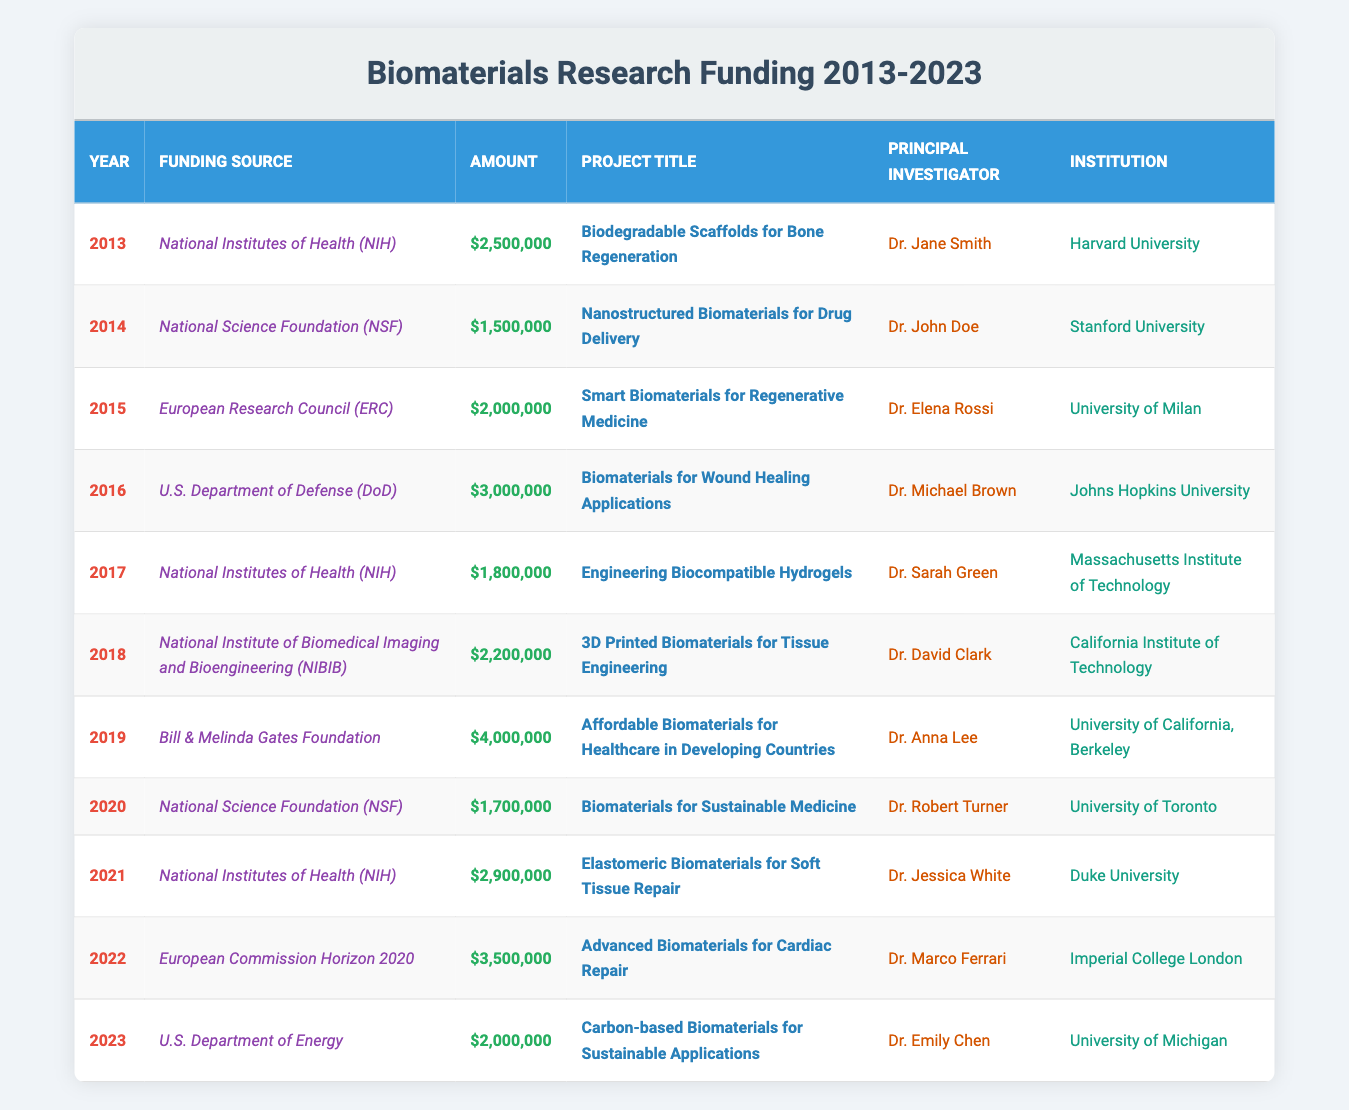What was the largest single funding amount for a biomaterials project during this period? Analyzing the amount column, the largest single funding amount is $4,000,000 which corresponds to the project titled "Affordable Biomaterials for Healthcare in Developing Countries" in 2019.
Answer: $4,000,000 How many projects were funded by the National Institutes of Health (NIH)? Counting the rows where the source is "National Institutes of Health (NIH)", we find 4 projects listed in the table: 2013, 2017, 2021.
Answer: 4 What is the total funding amount received by projects from the National Science Foundation (NSF)? The funding amounts for NSF are $1,500,000 in 2014 and $1,700,000 in 2020. Adding these gives $1,500,000 + $1,700,000 = $3,200,000.
Answer: $3,200,000 Was there a project funded by the Bill & Melinda Gates Foundation? The table shows that there is indeed a project funded by the Bill & Melinda Gates Foundation, specifically in 2019.
Answer: Yes Which project had the highest funding amount from the U.S. Department of Defense (DoD)? Only one project is listed from DoD, which is "Biomaterials for Wound Healing Applications" in 2016 with a funding amount of $3,000,000; thus, it has the highest funding.
Answer: Biomaterials for Wound Healing Applications How much funding did the European Commission Horizon 2020 provide, and in which year? The table shows that the European Commission Horizon 2020 provided $3,500,000 for the project "Advanced Biomaterials for Cardiac Repair" in 2022.
Answer: $3,500,000 in 2022 Which institution received the second-highest project funding, and how much was it? The second-highest funding is $3,500,000 for the project from the European Commission Horizon 2020 in 2022, which was conducted by Imperial College London.
Answer: Imperial College London, $3,500,000 What is the average funding amount from the National Institutes of Health (NIH)? The amounts from NIH are $2,500,000 (2013), $1,800,000 (2017), and $2,900,000 (2021). The average is calculated as ($2,500,000 + $1,800,000 + $2,900,000) / 3 = $2,066,667.
Answer: $2,066,667 Identify the principal investigator with the highest total funding associated with projects listed. Summing the funding amounts for each principal investigator from the table: Dr. Jane Smith = $2,500,000, Dr. John Doe = $1,500,000, Dr. Elena Rossi = $2,000,000, Dr. Michael Brown = $3,000,000, Dr. Sarah Green = $1,800,000, Dr. David Clark = $2,200,000, Dr. Anna Lee = $4,000,000, Dr. Robert Turner = $1,700,000, Dr. Jessica White = $2,900,000, Dr. Marco Ferrari = $3,500,000, Dr. Emily Chen = $2,000,000. The highest total is for Dr. Anna Lee with $4,000,000.
Answer: Dr. Anna Lee How many unique funding sources are listed in the table? By reviewing the distinct funding sources in the table, we can see that there are 8 unique ones: NIH, NSF, ERC, DoD, NIBIB, Bill & Melinda Gates Foundation, European Commission Horizon 2020, and U.S. Department of Energy, giving a total of 8.
Answer: 8 